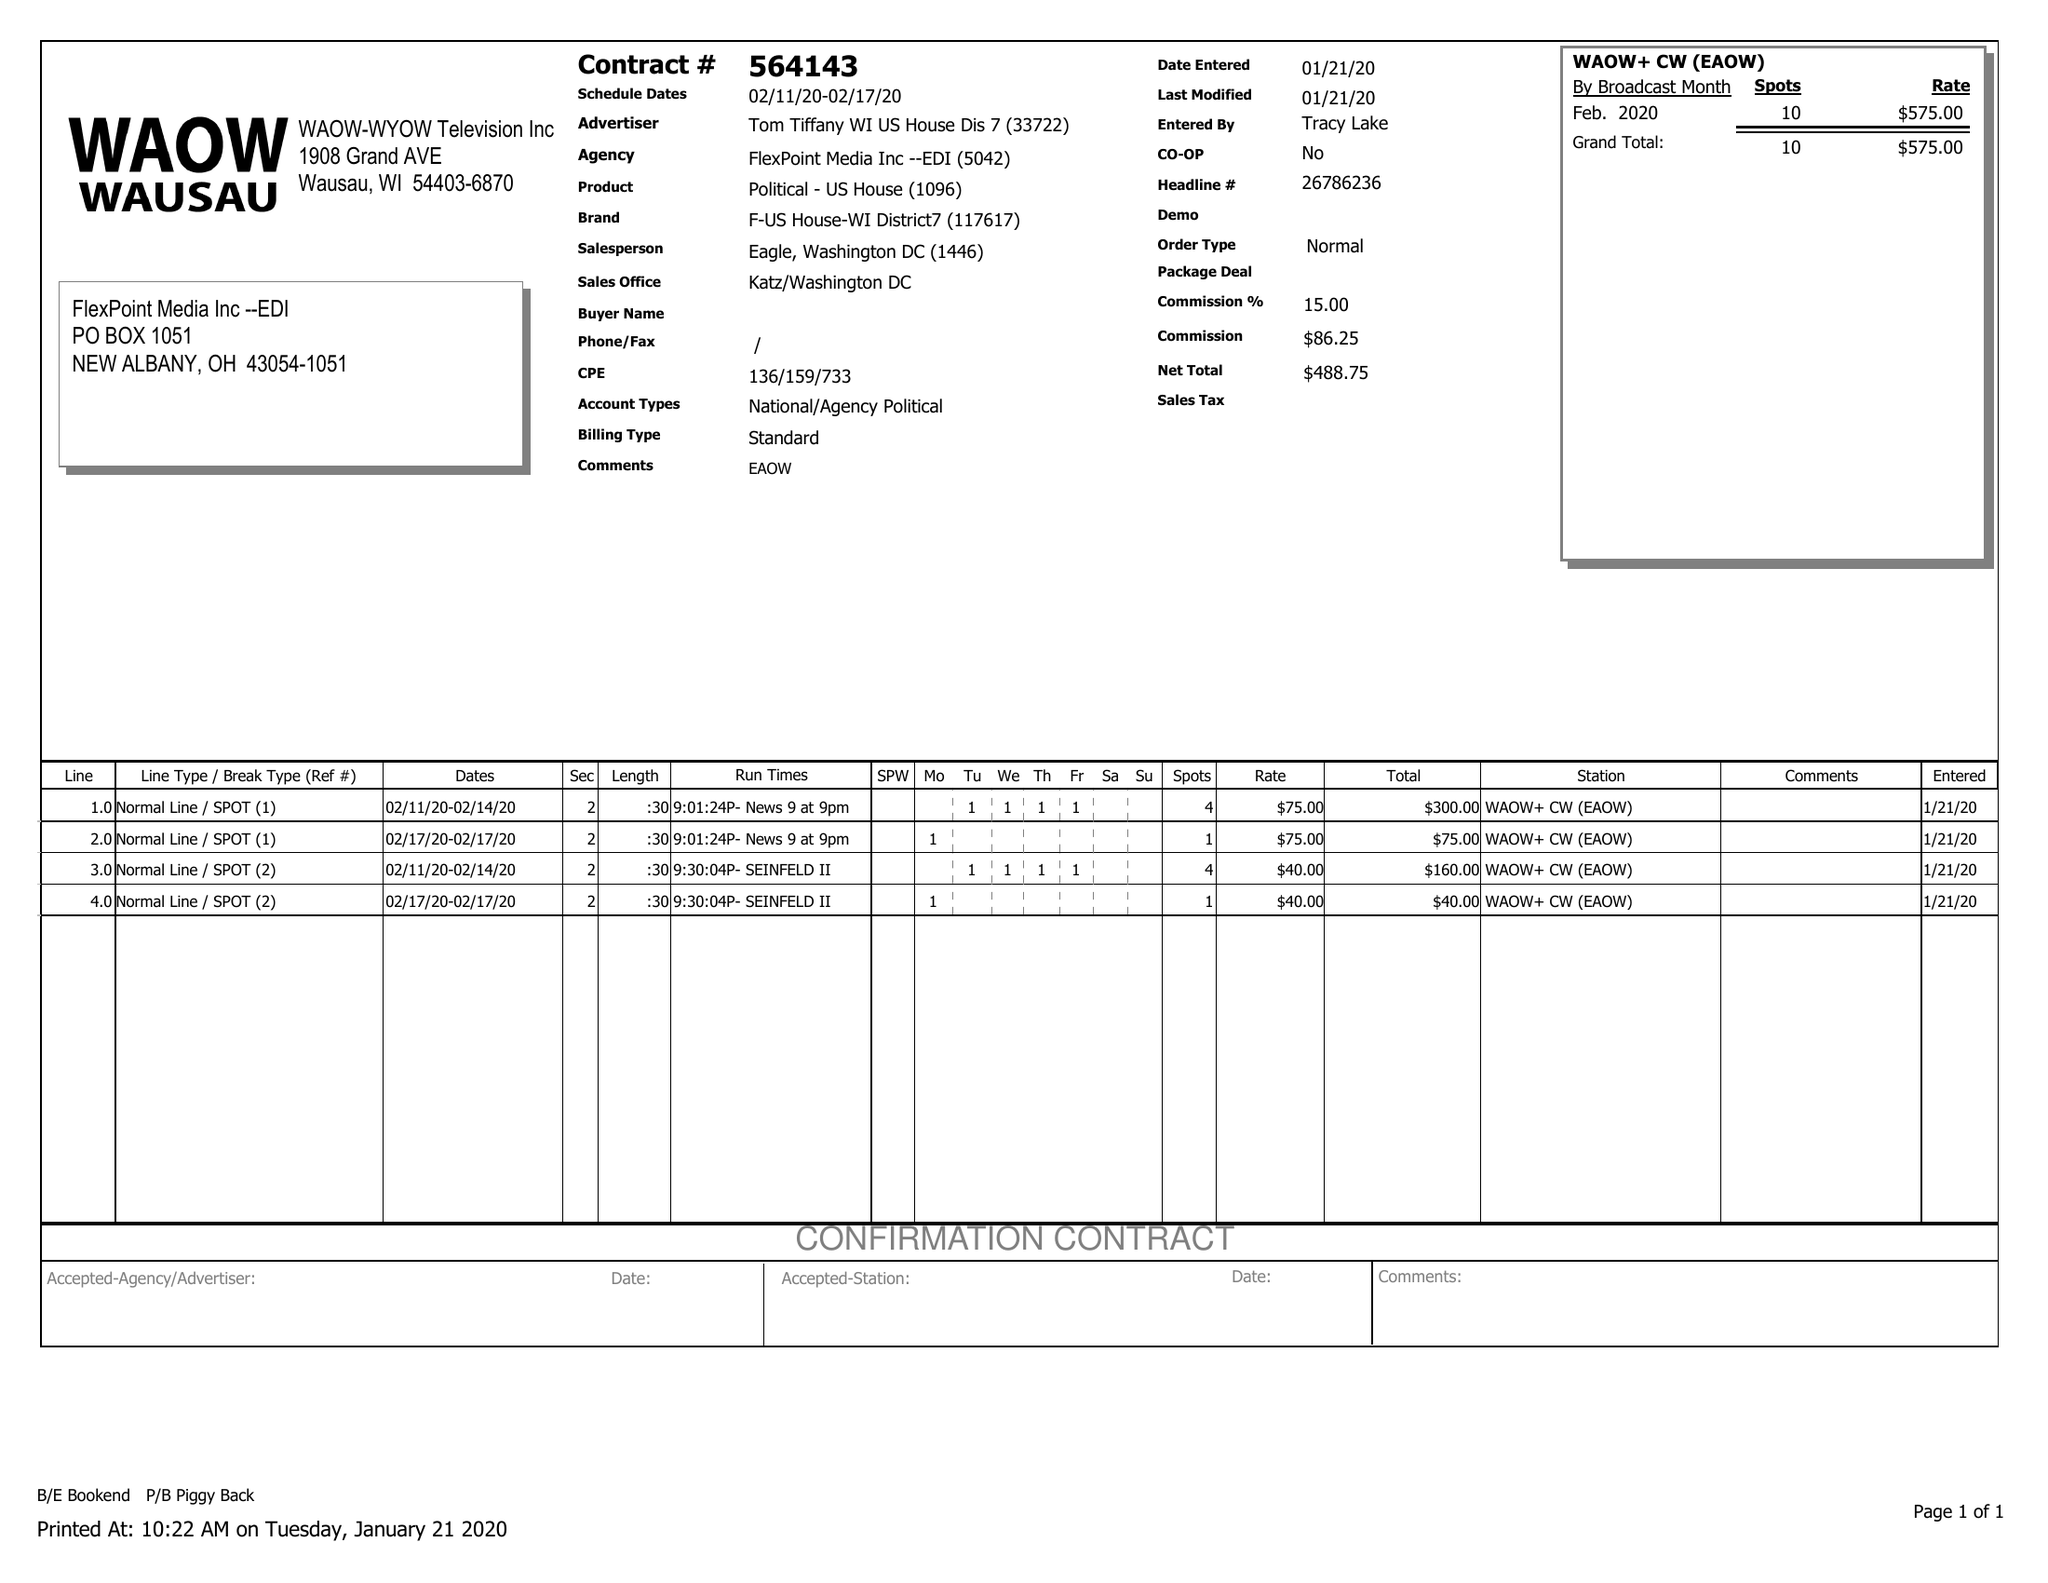What is the value for the flight_from?
Answer the question using a single word or phrase. 02/11/20 